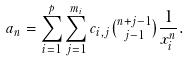<formula> <loc_0><loc_0><loc_500><loc_500>a _ { n } = \sum _ { i = 1 } ^ { p } \sum _ { j = 1 } ^ { m _ { i } } c _ { i , j } \tbinom { n + j - 1 } { j - 1 } \frac { 1 } { x _ { i } ^ { n } } .</formula> 